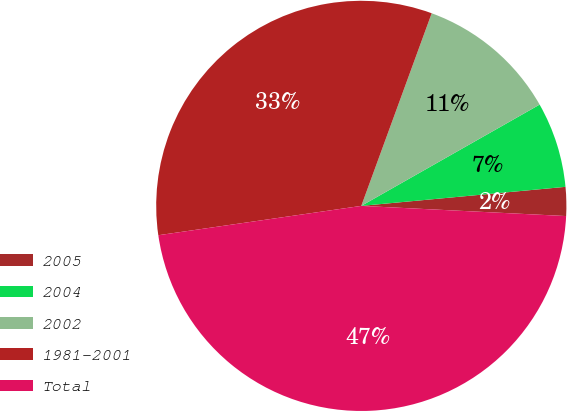<chart> <loc_0><loc_0><loc_500><loc_500><pie_chart><fcel>2005<fcel>2004<fcel>2002<fcel>1981-2001<fcel>Total<nl><fcel>2.27%<fcel>6.74%<fcel>11.2%<fcel>32.86%<fcel>46.92%<nl></chart> 